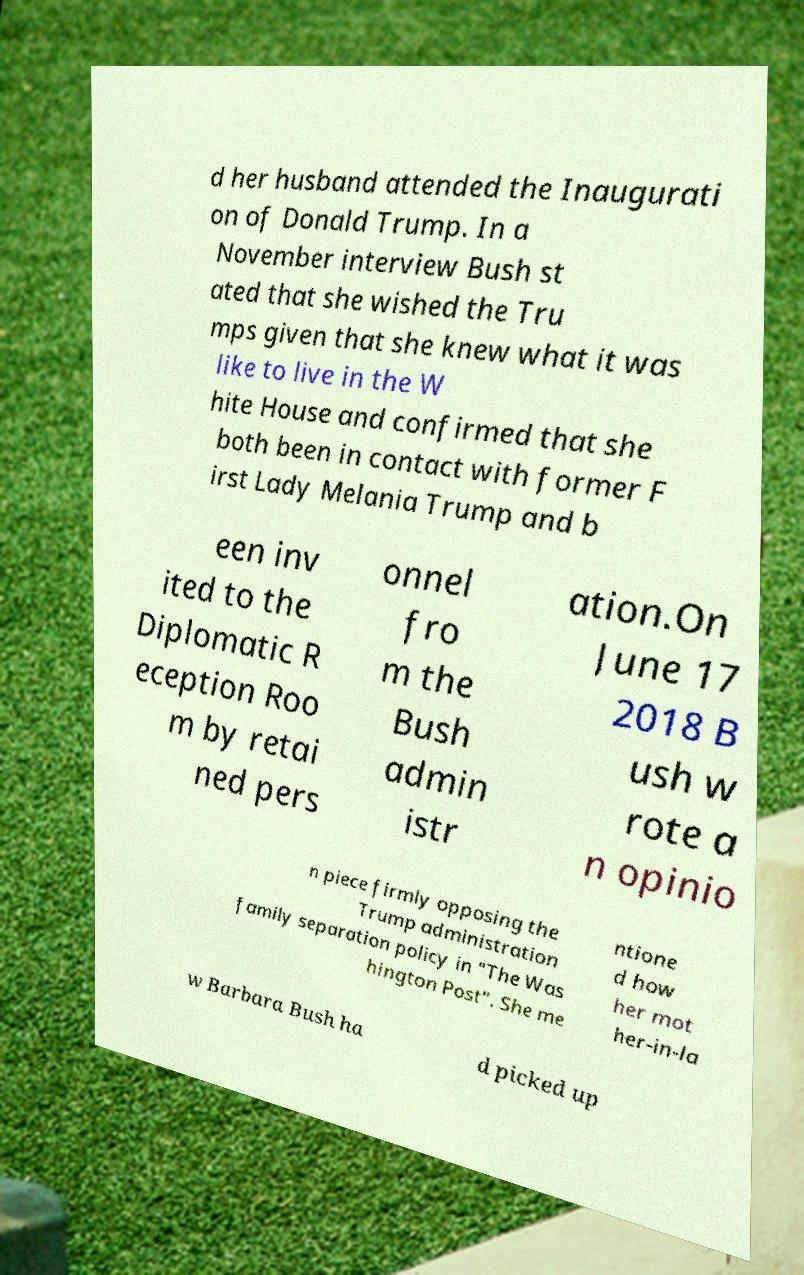What messages or text are displayed in this image? I need them in a readable, typed format. d her husband attended the Inaugurati on of Donald Trump. In a November interview Bush st ated that she wished the Tru mps given that she knew what it was like to live in the W hite House and confirmed that she both been in contact with former F irst Lady Melania Trump and b een inv ited to the Diplomatic R eception Roo m by retai ned pers onnel fro m the Bush admin istr ation.On June 17 2018 B ush w rote a n opinio n piece firmly opposing the Trump administration family separation policy in "The Was hington Post". She me ntione d how her mot her-in-la w Barbara Bush ha d picked up 